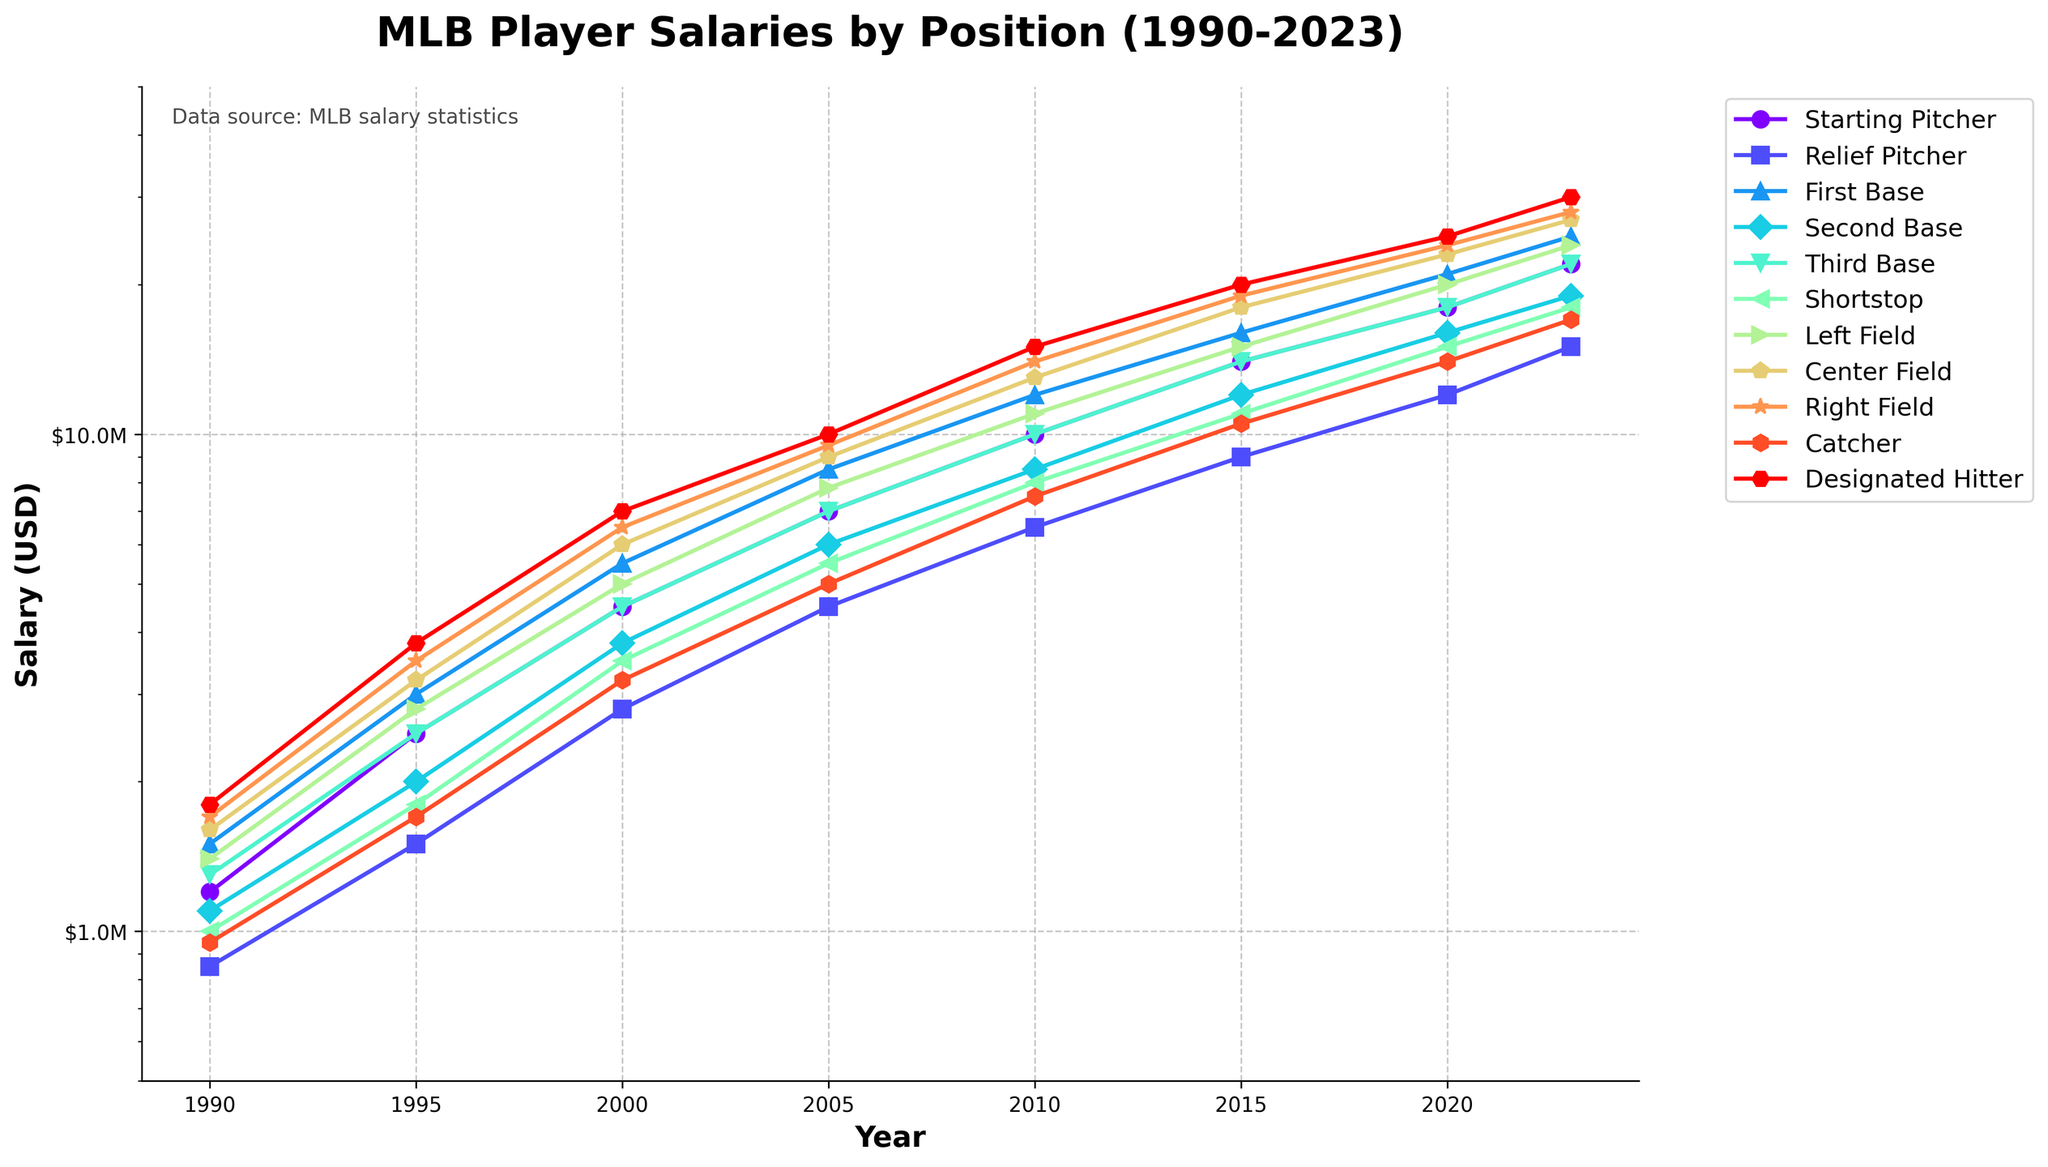Which position experiences the highest salary growth from 1990 to 2023? Examine the salaries of each position in 1990 and 2023. Calculate the difference between 1990 and 2023 for each position, and find the position with the largest difference. For example, the Starting Pitcher salary grew from $1,200,000 in 1990 to $22,000,000 in 2023, a difference of $20,800,000. Repeat for all positions and compare.
Answer: Designated Hitter Which position had the highest salary in 2023? Look at the salary values for all positions in the year 2023. Identify the position with the largest salary value. In 2023, the Designated Hitter has a salary of $30,000,000, which is the highest among all positions.
Answer: Designated Hitter How much more did Right Fielders earn on average compared to Shortstops in 2023? Identify the salary of Right Fielders and Shortstops in 2023. Subtract the salary of Shortstops from the salary of Right Fielders. In 2023, Right Fielders earned $28,000,000, and Shortstops earned $18,000,000, so $28,000,000 - $18,000,000 = $10,000,000.
Answer: $10,000,000 Which position had the slowest salary growth rate from 1990 to 2023? Calculate the salary increase for each position from 1990 to 2023 by subtracting the 1990 salary from the 2023 salary. Then, compare the increases to find the smallest one. Relief Pitchers had a salary increase from $850,000 to $15,000,000, which is a $14,150,000 increase, the smallest among all positions.
Answer: Relief Pitcher What is the average salary of all positions in 2023? Sum the 2023 salaries for all positions and then divide by the number of positions (which is 11). ($22,000,000 + $15,000,000 + $25,000,000 + $19,000,000 + $22,000,000 + $18,000,000 + $24,000,000 + $27,000,000 + $28,000,000 + $17,000,000 + $30,000,000) / 11 = $22,181,818.18
Answer: $22,181,818.18 Which position had the most consistent salary growth from 1990 to 2023? Observe the trend lines for each position in the plot. Identify the position whose salary line increases steadily without sudden peaks or dips. By visual inspection, Starting Pitchers have a relatively smooth and consistent upward trend from 1990 to 2023.
Answer: Starting Pitcher 